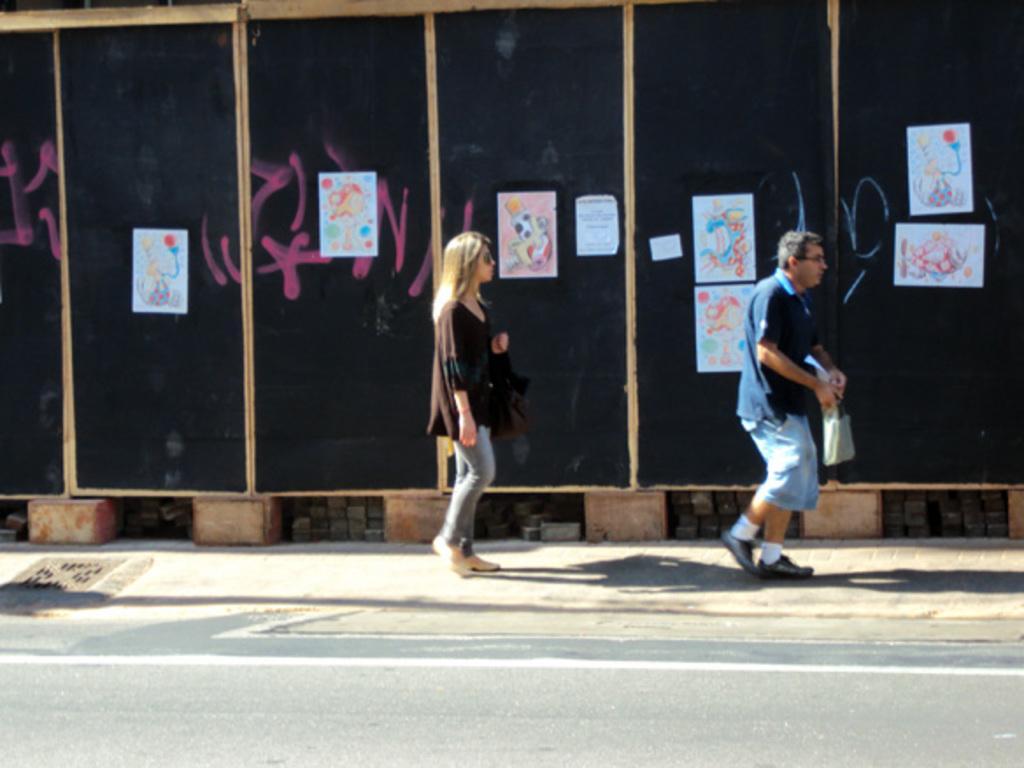Can you describe this image briefly? In this image we can see two persons standing on the ground. One person wearing a blue dress and spectacles. One woman is carrying a bag. In the background, we can see a group of photos pasted on the wall. 